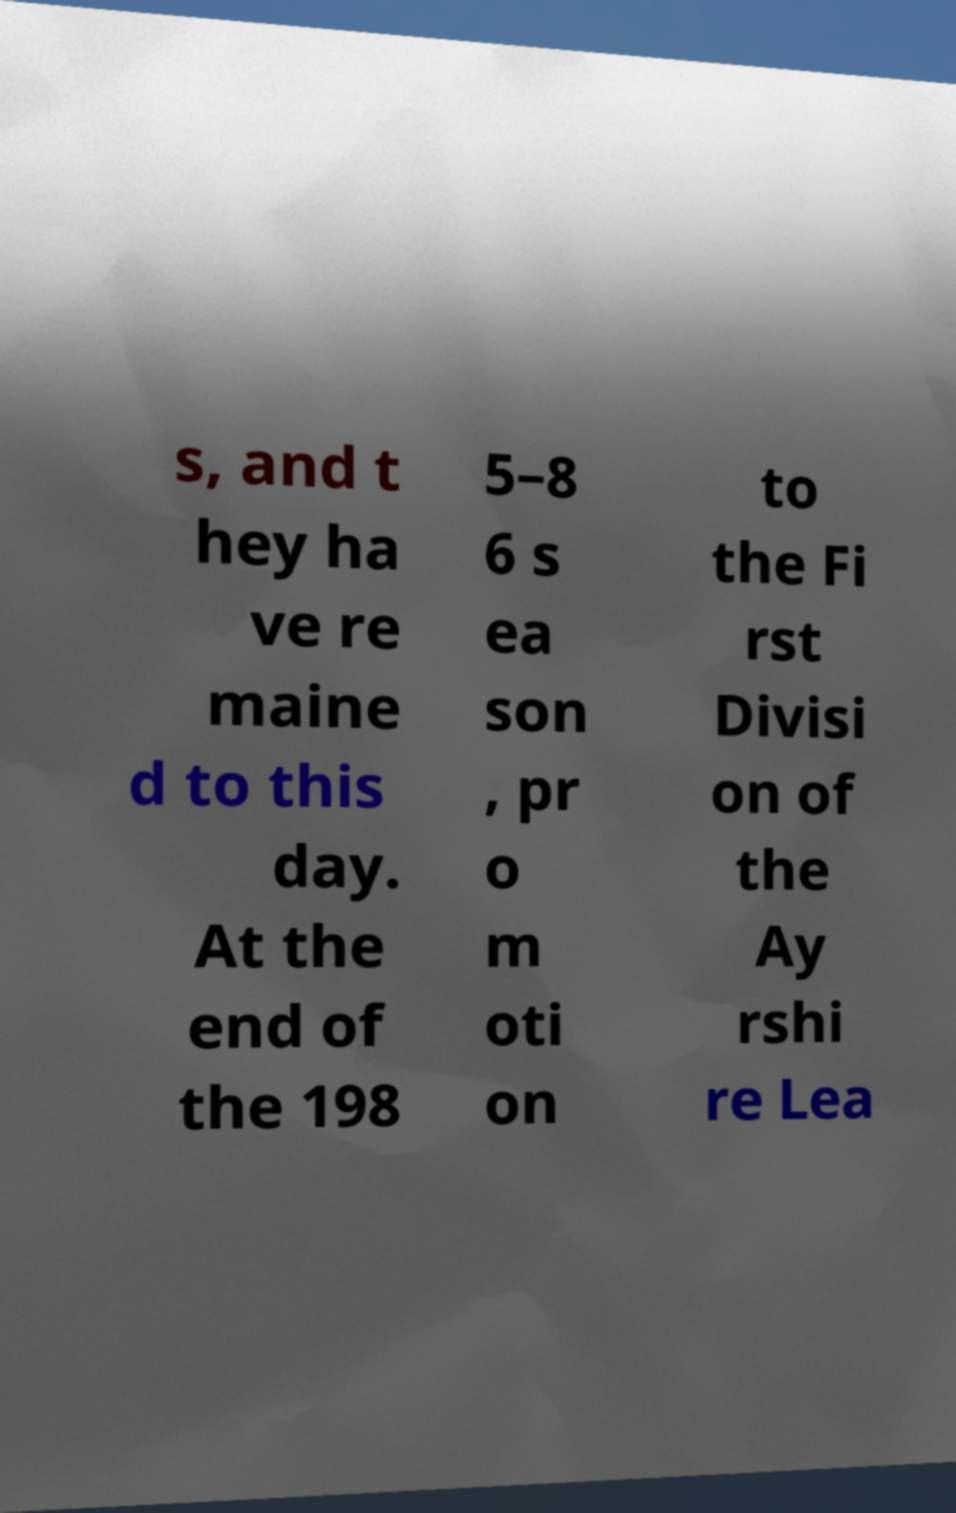Please identify and transcribe the text found in this image. s, and t hey ha ve re maine d to this day. At the end of the 198 5–8 6 s ea son , pr o m oti on to the Fi rst Divisi on of the Ay rshi re Lea 